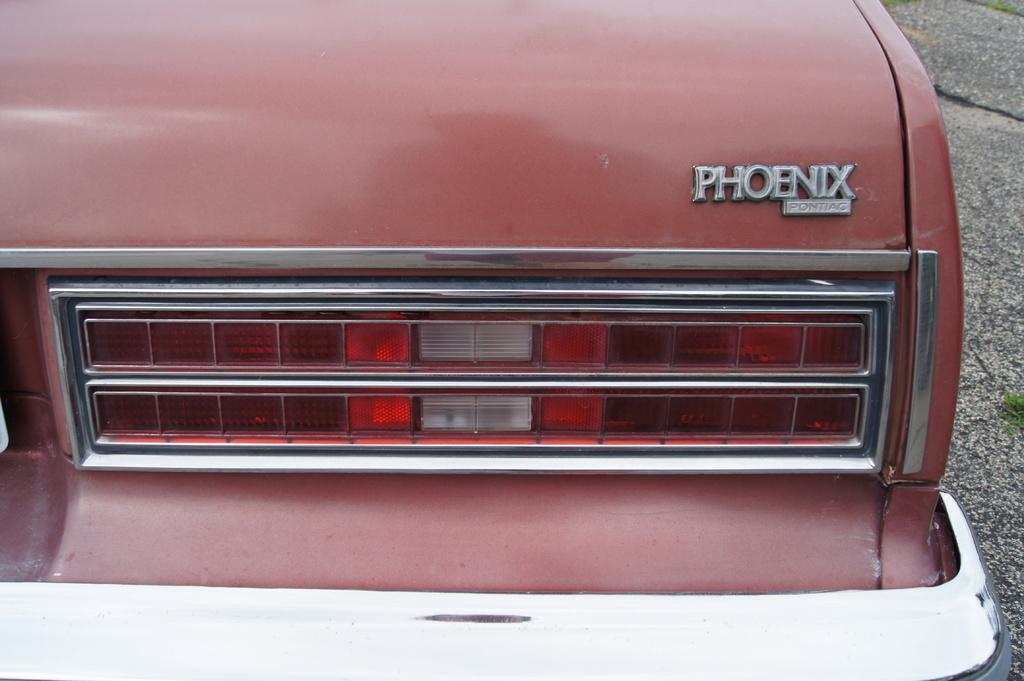What color is the vehicle in the image? The vehicle in the image is pink. What part of the vehicle has a pink color? The tail light of the vehicle is pink. Is there any text visible on the vehicle? Yes, there is text written on the right side of the vehicle. What type of shoe is hanging from the line in the image? There is no line or shoe present in the image; it only features a pink-colored vehicle with a pink tail light and text on the right side. 